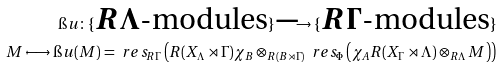<formula> <loc_0><loc_0><loc_500><loc_500>\i u \colon \{ \text {$R\Lambda$-modules} \} \longrightarrow \{ \text {$R\Gamma$-modules} \} \\ M \longmapsto \i u ( M ) = \ r e s _ { R \Gamma } \left ( R ( X _ { \Lambda } \rtimes \Gamma ) \chi _ { B } \otimes _ { R ( B \rtimes \Gamma ) } \ r e s _ { \Phi } \left ( \chi _ { A } R ( X _ { \Gamma } \rtimes \Lambda ) \otimes _ { R \Lambda } M \right ) \right )</formula> 